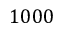Convert formula to latex. <formula><loc_0><loc_0><loc_500><loc_500>1 0 0 0</formula> 